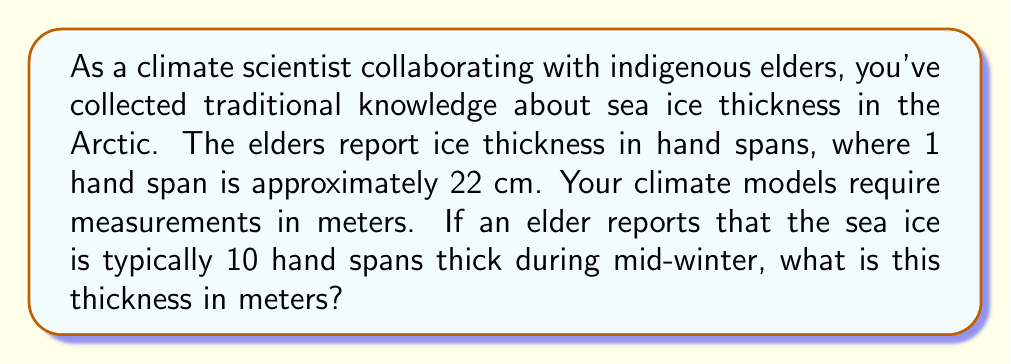Help me with this question. To solve this problem, we need to convert from hand spans to meters. Let's break it down step by step:

1. First, let's establish the given information:
   - 1 hand span = 22 cm
   - The reported ice thickness = 10 hand spans

2. Convert hand spans to centimeters:
   $$ 10 \text{ hand spans} \times \frac{22 \text{ cm}}{1 \text{ hand span}} = 220 \text{ cm} $$

3. Now, we need to convert centimeters to meters:
   - We know that 1 m = 100 cm
   - So, we can divide our result by 100:

   $$ 220 \text{ cm} \times \frac{1 \text{ m}}{100 \text{ cm}} = 2.20 \text{ m} $$

Therefore, 10 hand spans is equivalent to 2.20 meters.
Answer: 2.20 m 